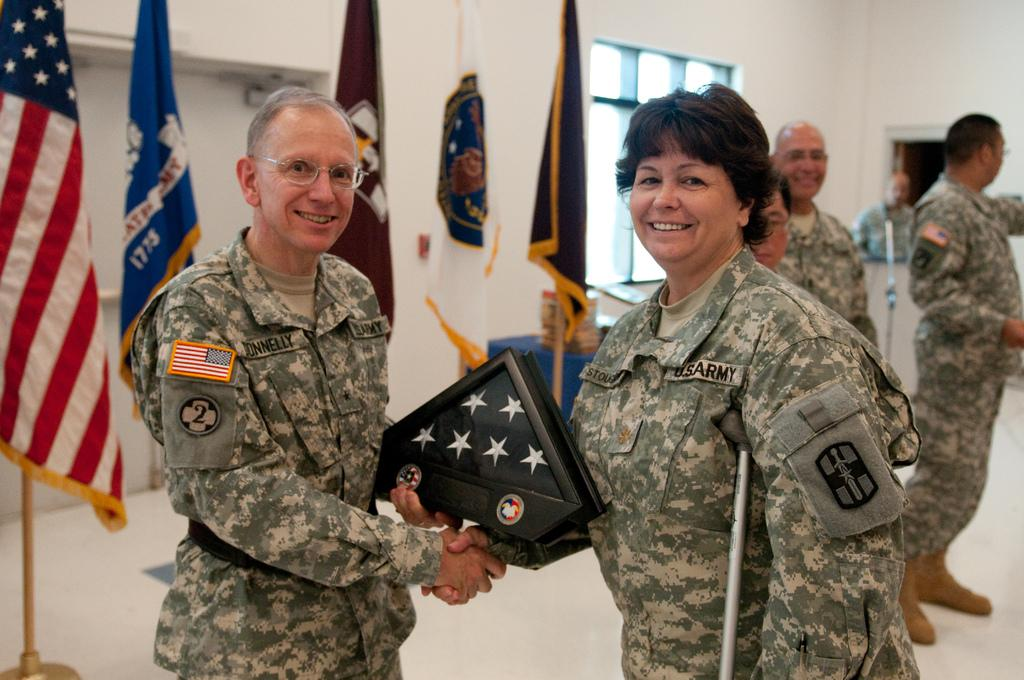What are the people in the image doing? There are persons standing on the floor in the image. Can you describe what one of the persons is holding? One of the persons is holding an object in their hands. What can be seen in the background of the image? There are flags, flag posts, a window, and walls in the background of the image. What type of bun is being used to fuel the science experiment in the image? There is no bun or science experiment present in the image. What type of fuel is being used to power the flags in the image? There is no fuel or indication of powering the flags in the image; they are simply hanging on flag posts. 